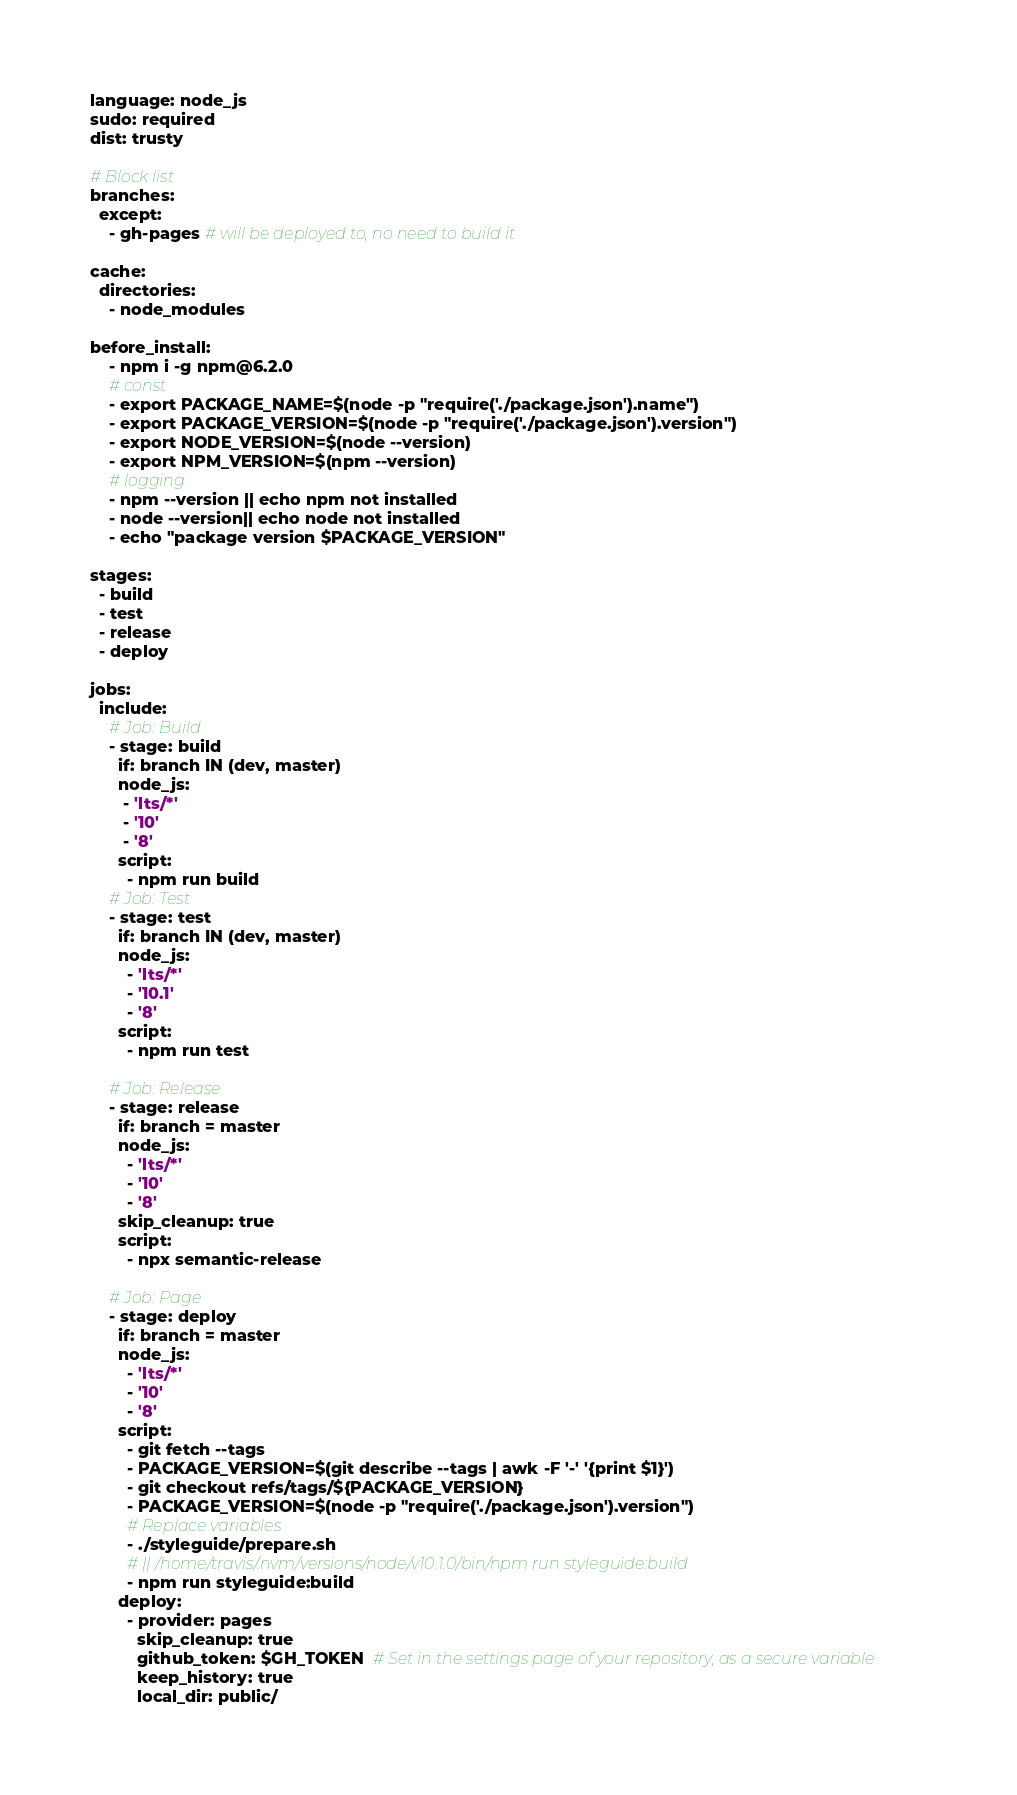<code> <loc_0><loc_0><loc_500><loc_500><_YAML_>language: node_js
sudo: required
dist: trusty

# Block list
branches:
  except:
    - gh-pages # will be deployed to, no need to build it

cache:
  directories:
    - node_modules

before_install:
    - npm i -g npm@6.2.0
    # const
    - export PACKAGE_NAME=$(node -p "require('./package.json').name")
    - export PACKAGE_VERSION=$(node -p "require('./package.json').version")
    - export NODE_VERSION=$(node --version)
    - export NPM_VERSION=$(npm --version)
    # logging
    - npm --version || echo npm not installed
    - node --version|| echo node not installed
    - echo "package version $PACKAGE_VERSION"

stages:
  - build
  - test
  - release
  - deploy

jobs:
  include:
    # Job: Build
    - stage: build
      if: branch IN (dev, master)
      node_js:
       - 'lts/*'
       - '10'
       - '8'
      script:
        - npm run build
    # Job: Test
    - stage: test
      if: branch IN (dev, master)
      node_js:
        - 'lts/*'
        - '10.1'
        - '8'
      script:
        - npm run test

    # Job: Release
    - stage: release
      if: branch = master
      node_js:
        - 'lts/*'
        - '10'
        - '8'
      skip_cleanup: true
      script:
        - npx semantic-release

    # Job: Page
    - stage: deploy
      if: branch = master
      node_js:
        - 'lts/*'
        - '10'
        - '8'
      script:
        - git fetch --tags
        - PACKAGE_VERSION=$(git describe --tags | awk -F '-' '{print $1}')
        - git checkout refs/tags/${PACKAGE_VERSION}
        - PACKAGE_VERSION=$(node -p "require('./package.json').version")
        # Replace variables
        - ./styleguide/prepare.sh
        # || /home/travis/.nvm/versions/node/v10.1.0/bin/npm run styleguide:build
        - npm run styleguide:build
      deploy:
        - provider: pages
          skip_cleanup: true
          github_token: $GH_TOKEN  # Set in the settings page of your repository, as a secure variable
          keep_history: true
          local_dir: public/
</code> 